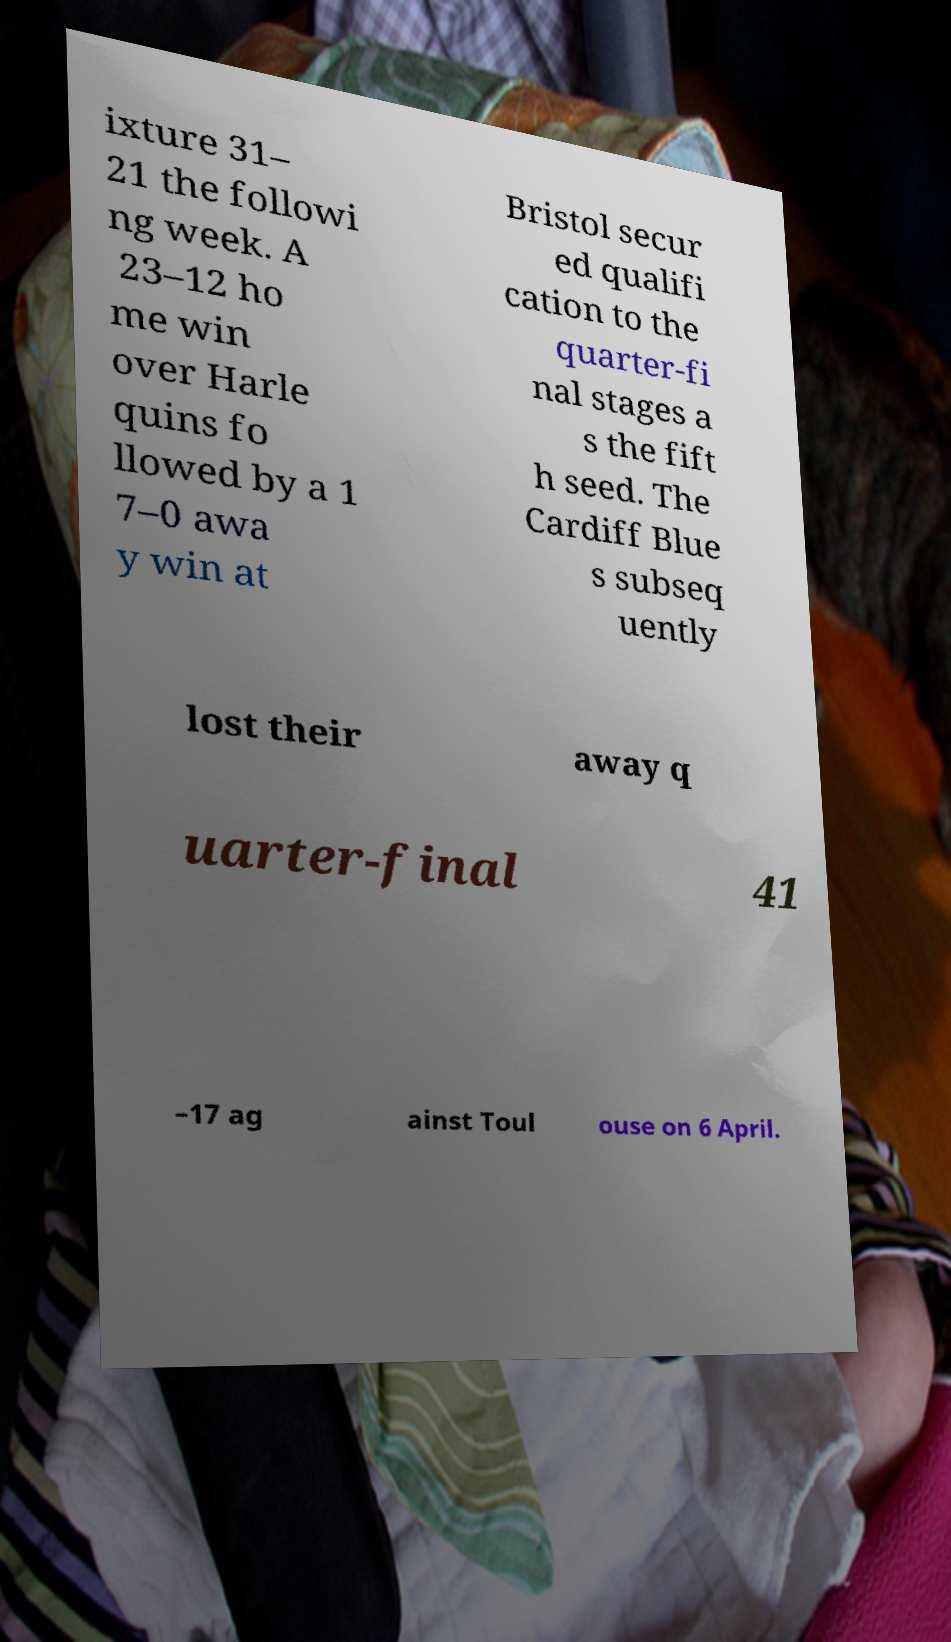For documentation purposes, I need the text within this image transcribed. Could you provide that? ixture 31– 21 the followi ng week. A 23–12 ho me win over Harle quins fo llowed by a 1 7–0 awa y win at Bristol secur ed qualifi cation to the quarter-fi nal stages a s the fift h seed. The Cardiff Blue s subseq uently lost their away q uarter-final 41 –17 ag ainst Toul ouse on 6 April. 